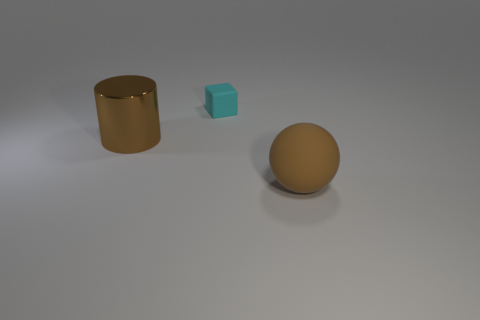Is there any other thing that is the same size as the block?
Keep it short and to the point. No. How many rubber objects are the same size as the brown cylinder?
Provide a short and direct response. 1. Do the matte thing that is in front of the cyan block and the large object that is behind the brown rubber ball have the same color?
Your answer should be very brief. Yes. There is a brown object right of the large brown cylinder; what shape is it?
Ensure brevity in your answer.  Sphere. The sphere has what color?
Provide a succinct answer. Brown. The object that is made of the same material as the cyan block is what shape?
Provide a succinct answer. Sphere. Is the size of the object that is behind the cylinder the same as the brown matte object?
Your answer should be very brief. No. How many objects are large things that are to the left of the matte block or brown things that are behind the big brown matte ball?
Provide a short and direct response. 1. There is a large object to the left of the brown rubber sphere; is its color the same as the tiny rubber cube?
Offer a terse response. No. What number of shiny objects are either small cyan blocks or big balls?
Give a very brief answer. 0. 